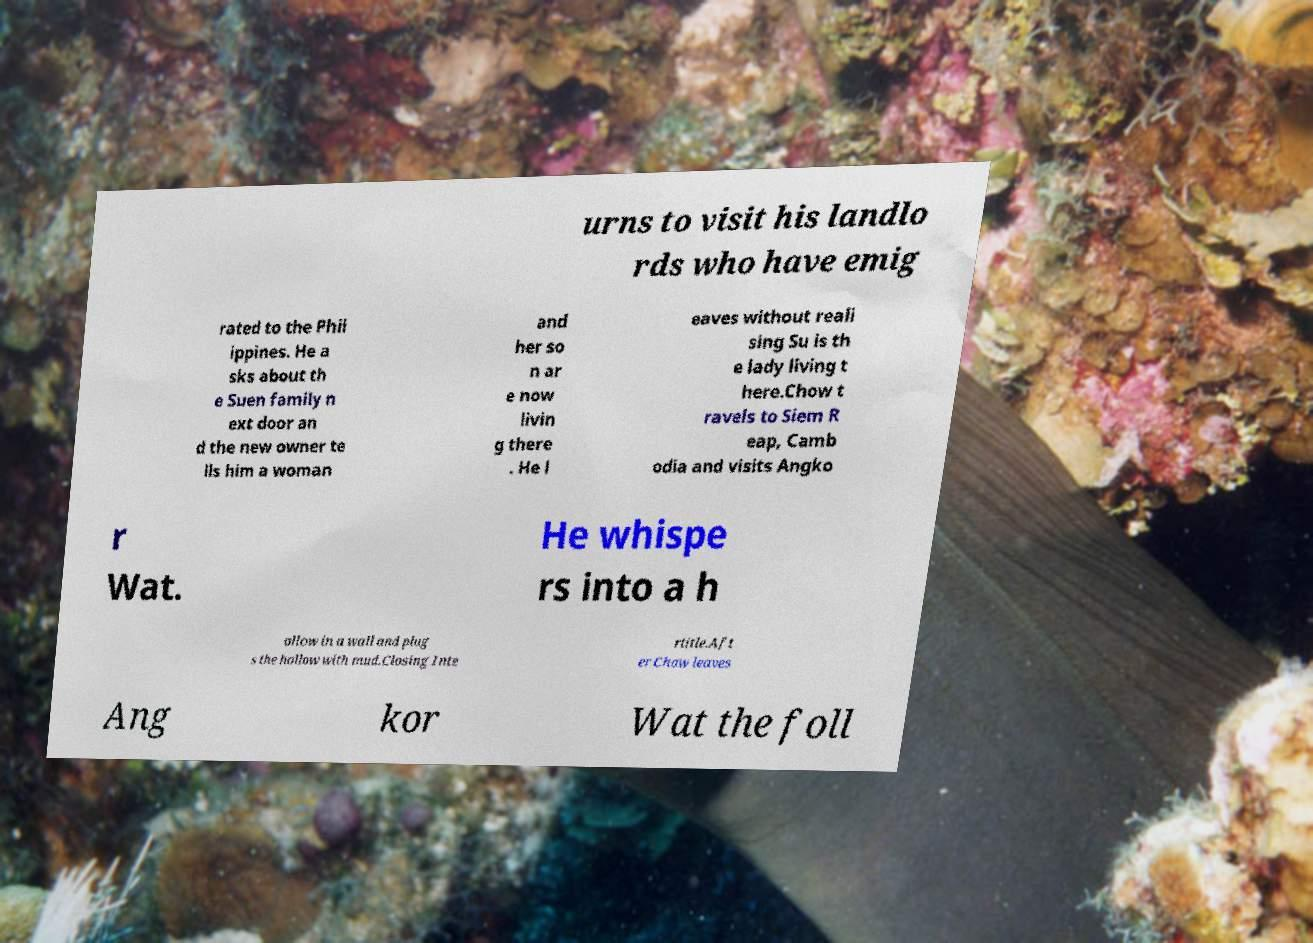Could you assist in decoding the text presented in this image and type it out clearly? urns to visit his landlo rds who have emig rated to the Phil ippines. He a sks about th e Suen family n ext door an d the new owner te lls him a woman and her so n ar e now livin g there . He l eaves without reali sing Su is th e lady living t here.Chow t ravels to Siem R eap, Camb odia and visits Angko r Wat. He whispe rs into a h ollow in a wall and plug s the hollow with mud.Closing Inte rtitle.Aft er Chow leaves Ang kor Wat the foll 